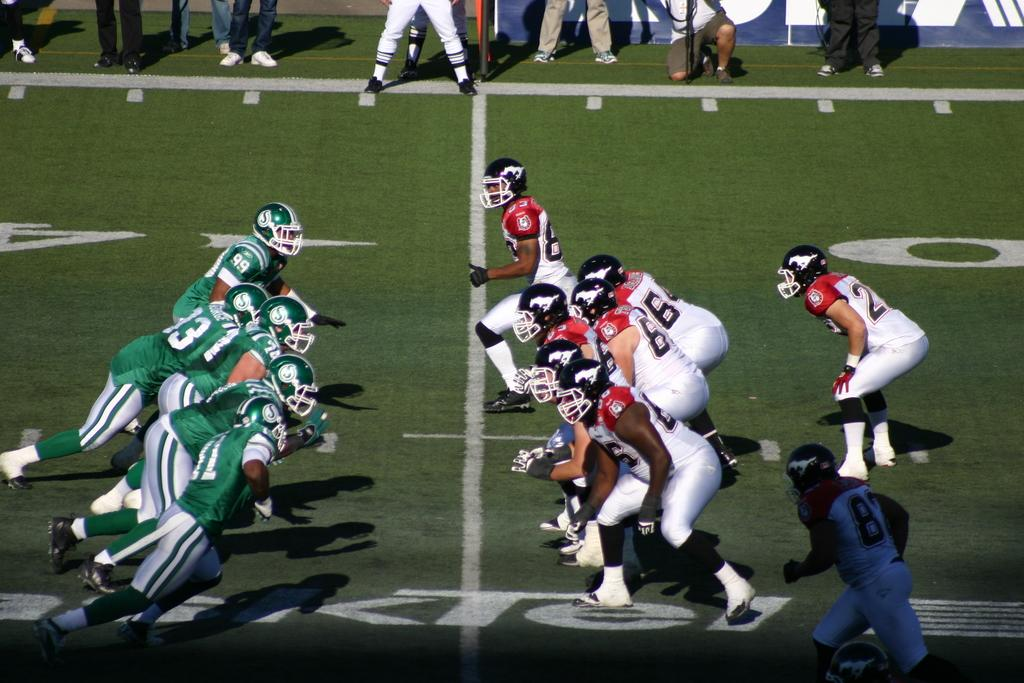Who or what can be seen in the image? There are people in the image. What are some of the people wearing? Some of the people are wearing helmets. What can be observed on the ground in the image? There are lines on the ground in the image. What type of market can be seen in the image? There is no market present in the image; it features people and lines on the ground. How much wealth is visible in the image? There is no indication of wealth in the image, as it focuses on people and lines on the ground. 